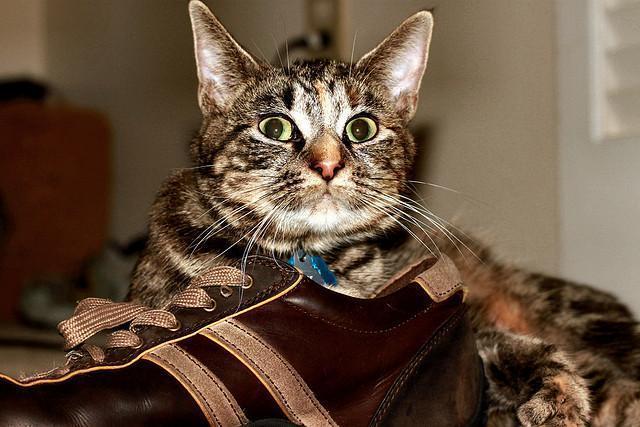How many suitcases are there?
Give a very brief answer. 1. How many people are visible in this image?
Give a very brief answer. 0. 